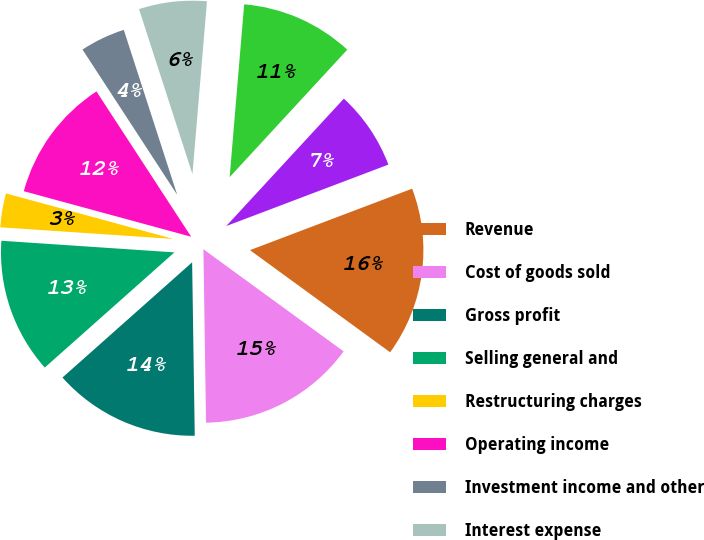Convert chart to OTSL. <chart><loc_0><loc_0><loc_500><loc_500><pie_chart><fcel>Revenue<fcel>Cost of goods sold<fcel>Gross profit<fcel>Selling general and<fcel>Restructuring charges<fcel>Operating income<fcel>Investment income and other<fcel>Interest expense<fcel>Earnings before income tax<fcel>Income tax expense<nl><fcel>15.79%<fcel>14.74%<fcel>13.68%<fcel>12.63%<fcel>3.16%<fcel>11.58%<fcel>4.21%<fcel>6.32%<fcel>10.53%<fcel>7.37%<nl></chart> 